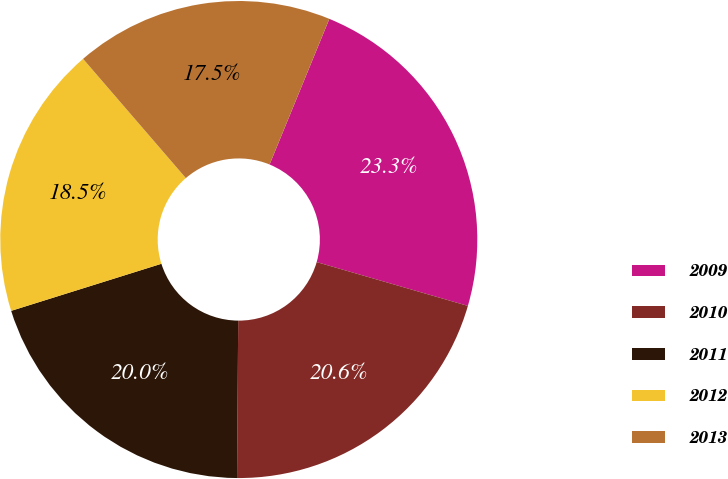<chart> <loc_0><loc_0><loc_500><loc_500><pie_chart><fcel>2009<fcel>2010<fcel>2011<fcel>2012<fcel>2013<nl><fcel>23.29%<fcel>20.63%<fcel>20.05%<fcel>18.51%<fcel>17.52%<nl></chart> 